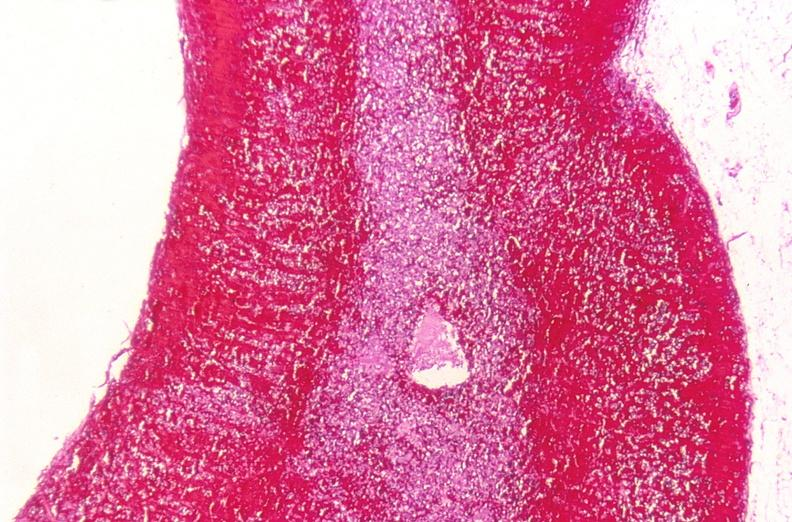where is this part in the figure?
Answer the question using a single word or phrase. Endocrine system 